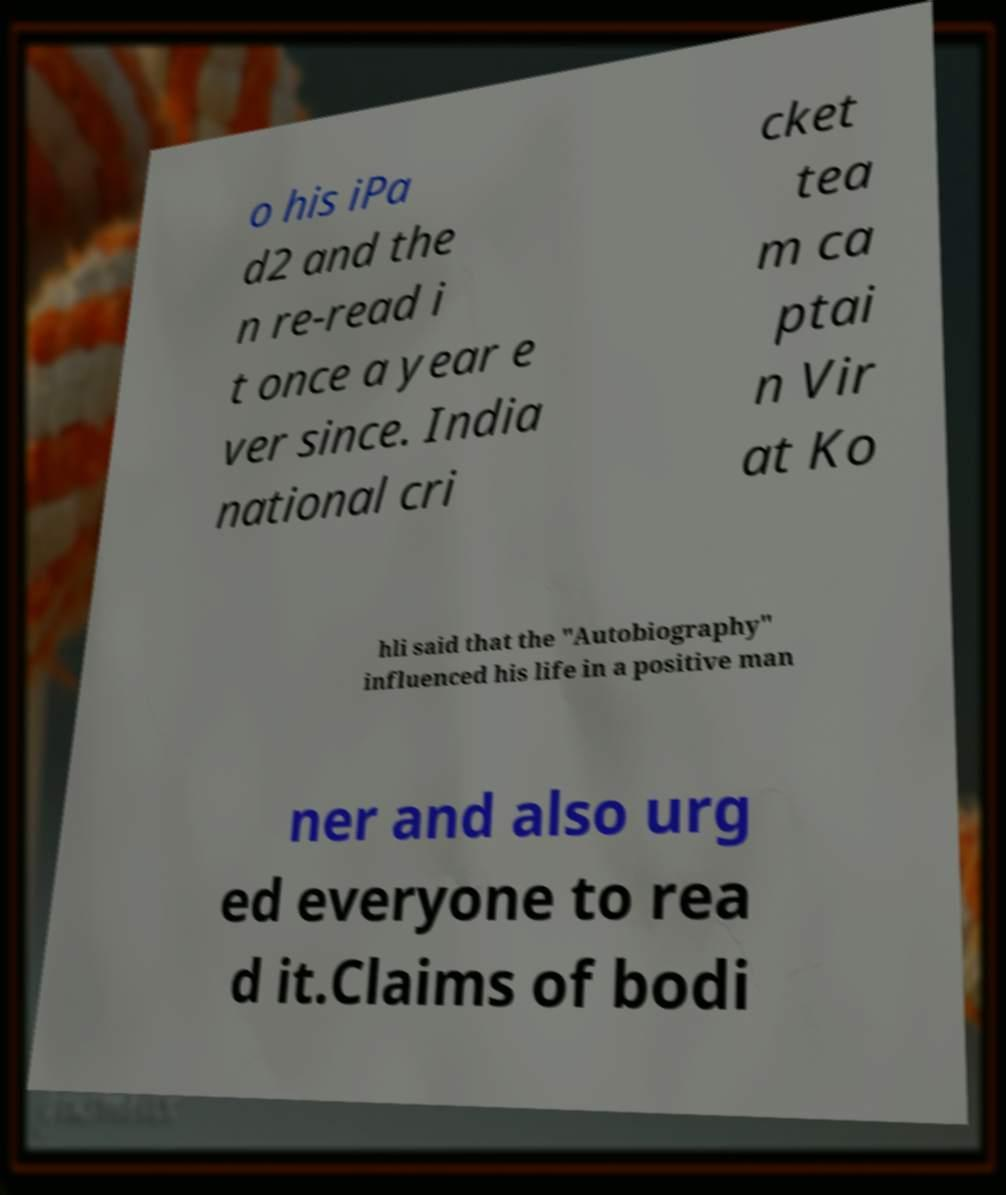Please read and relay the text visible in this image. What does it say? o his iPa d2 and the n re-read i t once a year e ver since. India national cri cket tea m ca ptai n Vir at Ko hli said that the "Autobiography" influenced his life in a positive man ner and also urg ed everyone to rea d it.Claims of bodi 